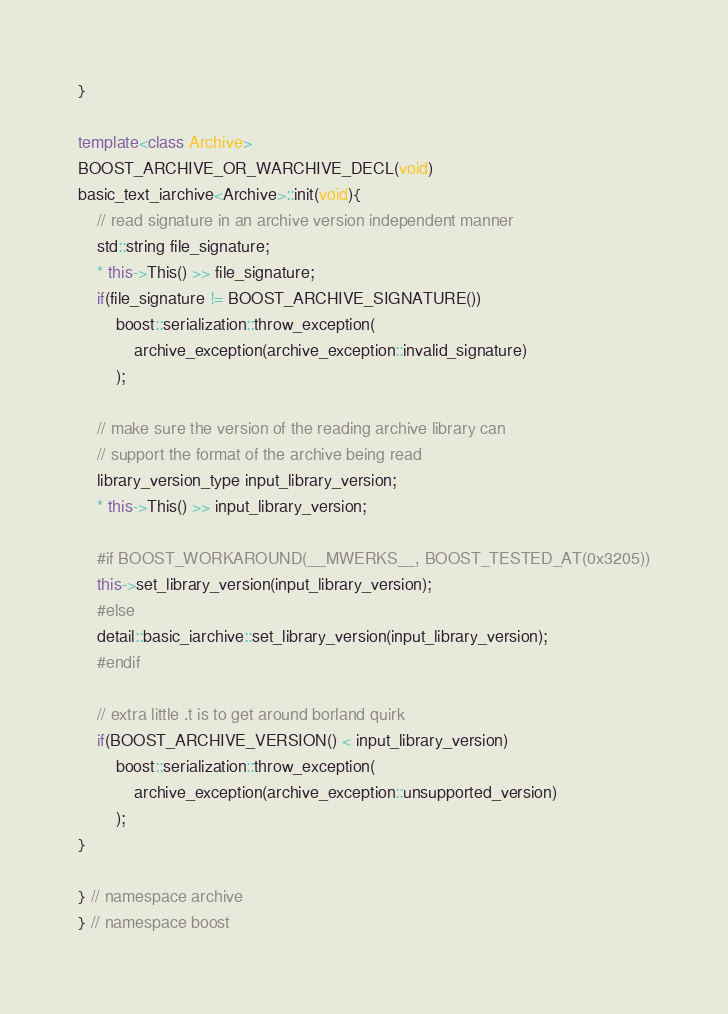Convert code to text. <code><loc_0><loc_0><loc_500><loc_500><_C++_>}

template<class Archive>
BOOST_ARCHIVE_OR_WARCHIVE_DECL(void)
basic_text_iarchive<Archive>::init(void){
    // read signature in an archive version independent manner
    std::string file_signature;
    * this->This() >> file_signature;
    if(file_signature != BOOST_ARCHIVE_SIGNATURE())
        boost::serialization::throw_exception(
            archive_exception(archive_exception::invalid_signature)
        );

    // make sure the version of the reading archive library can
    // support the format of the archive being read
    library_version_type input_library_version;
    * this->This() >> input_library_version;

    #if BOOST_WORKAROUND(__MWERKS__, BOOST_TESTED_AT(0x3205))
    this->set_library_version(input_library_version);
    #else
    detail::basic_iarchive::set_library_version(input_library_version);
    #endif

    // extra little .t is to get around borland quirk
    if(BOOST_ARCHIVE_VERSION() < input_library_version)
        boost::serialization::throw_exception(
            archive_exception(archive_exception::unsupported_version)
        );
}

} // namespace archive
} // namespace boost
</code> 